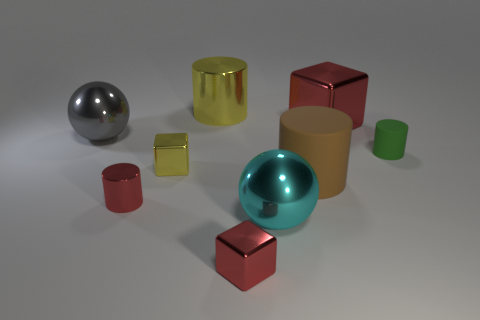There is a big object that is both behind the tiny yellow cube and in front of the big metallic block; what is it made of?
Your answer should be compact. Metal. How many other things are the same size as the cyan metallic ball?
Make the answer very short. 4. What color is the small shiny cylinder?
Your answer should be very brief. Red. Is the color of the big cylinder that is right of the big cyan metallic object the same as the shiny sphere behind the tiny green cylinder?
Your answer should be very brief. No. What is the size of the yellow metallic cylinder?
Give a very brief answer. Large. There is a cylinder to the right of the large red metallic thing; what is its size?
Offer a very short reply. Small. There is a tiny object that is both in front of the brown matte cylinder and behind the cyan metal ball; what shape is it?
Your answer should be compact. Cylinder. What number of other things are the same shape as the small yellow object?
Your response must be concise. 2. The shiny cylinder that is the same size as the yellow shiny cube is what color?
Make the answer very short. Red. How many things are green matte things or large things?
Offer a very short reply. 6. 